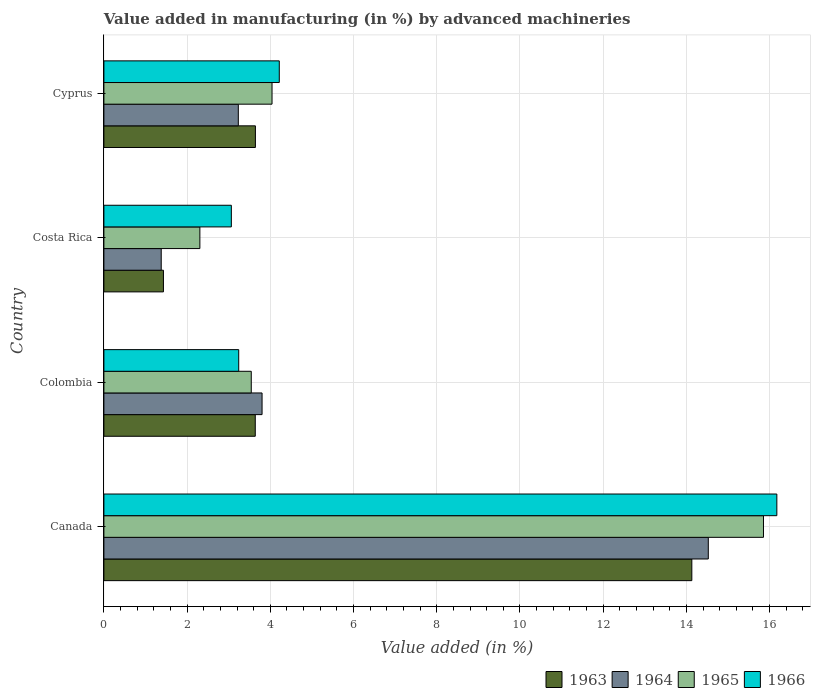Are the number of bars per tick equal to the number of legend labels?
Your answer should be compact. Yes. Are the number of bars on each tick of the Y-axis equal?
Your answer should be very brief. Yes. How many bars are there on the 1st tick from the bottom?
Give a very brief answer. 4. What is the label of the 1st group of bars from the top?
Offer a terse response. Cyprus. In how many cases, is the number of bars for a given country not equal to the number of legend labels?
Keep it short and to the point. 0. What is the percentage of value added in manufacturing by advanced machineries in 1964 in Canada?
Make the answer very short. 14.53. Across all countries, what is the maximum percentage of value added in manufacturing by advanced machineries in 1966?
Make the answer very short. 16.17. Across all countries, what is the minimum percentage of value added in manufacturing by advanced machineries in 1966?
Ensure brevity in your answer.  3.06. In which country was the percentage of value added in manufacturing by advanced machineries in 1964 minimum?
Provide a short and direct response. Costa Rica. What is the total percentage of value added in manufacturing by advanced machineries in 1966 in the graph?
Make the answer very short. 26.69. What is the difference between the percentage of value added in manufacturing by advanced machineries in 1966 in Colombia and that in Costa Rica?
Make the answer very short. 0.18. What is the difference between the percentage of value added in manufacturing by advanced machineries in 1966 in Colombia and the percentage of value added in manufacturing by advanced machineries in 1965 in Costa Rica?
Make the answer very short. 0.93. What is the average percentage of value added in manufacturing by advanced machineries in 1966 per country?
Your answer should be very brief. 6.67. What is the difference between the percentage of value added in manufacturing by advanced machineries in 1963 and percentage of value added in manufacturing by advanced machineries in 1965 in Cyprus?
Provide a short and direct response. -0.4. What is the ratio of the percentage of value added in manufacturing by advanced machineries in 1965 in Costa Rica to that in Cyprus?
Your response must be concise. 0.57. Is the difference between the percentage of value added in manufacturing by advanced machineries in 1963 in Colombia and Cyprus greater than the difference between the percentage of value added in manufacturing by advanced machineries in 1965 in Colombia and Cyprus?
Offer a very short reply. Yes. What is the difference between the highest and the second highest percentage of value added in manufacturing by advanced machineries in 1963?
Ensure brevity in your answer.  10.49. What is the difference between the highest and the lowest percentage of value added in manufacturing by advanced machineries in 1964?
Make the answer very short. 13.15. What does the 3rd bar from the top in Colombia represents?
Your response must be concise. 1964. What does the 1st bar from the bottom in Costa Rica represents?
Provide a short and direct response. 1963. How many countries are there in the graph?
Your answer should be very brief. 4. Does the graph contain any zero values?
Give a very brief answer. No. How are the legend labels stacked?
Offer a very short reply. Horizontal. What is the title of the graph?
Offer a terse response. Value added in manufacturing (in %) by advanced machineries. Does "1994" appear as one of the legend labels in the graph?
Your answer should be very brief. No. What is the label or title of the X-axis?
Offer a terse response. Value added (in %). What is the label or title of the Y-axis?
Ensure brevity in your answer.  Country. What is the Value added (in %) of 1963 in Canada?
Provide a succinct answer. 14.13. What is the Value added (in %) of 1964 in Canada?
Offer a terse response. 14.53. What is the Value added (in %) in 1965 in Canada?
Offer a terse response. 15.85. What is the Value added (in %) of 1966 in Canada?
Provide a short and direct response. 16.17. What is the Value added (in %) of 1963 in Colombia?
Keep it short and to the point. 3.64. What is the Value added (in %) of 1964 in Colombia?
Offer a very short reply. 3.8. What is the Value added (in %) in 1965 in Colombia?
Make the answer very short. 3.54. What is the Value added (in %) of 1966 in Colombia?
Your answer should be very brief. 3.24. What is the Value added (in %) in 1963 in Costa Rica?
Provide a short and direct response. 1.43. What is the Value added (in %) in 1964 in Costa Rica?
Your answer should be compact. 1.38. What is the Value added (in %) of 1965 in Costa Rica?
Your answer should be very brief. 2.31. What is the Value added (in %) of 1966 in Costa Rica?
Provide a short and direct response. 3.06. What is the Value added (in %) in 1963 in Cyprus?
Offer a very short reply. 3.64. What is the Value added (in %) in 1964 in Cyprus?
Ensure brevity in your answer.  3.23. What is the Value added (in %) of 1965 in Cyprus?
Ensure brevity in your answer.  4.04. What is the Value added (in %) of 1966 in Cyprus?
Ensure brevity in your answer.  4.22. Across all countries, what is the maximum Value added (in %) in 1963?
Keep it short and to the point. 14.13. Across all countries, what is the maximum Value added (in %) of 1964?
Offer a very short reply. 14.53. Across all countries, what is the maximum Value added (in %) of 1965?
Offer a very short reply. 15.85. Across all countries, what is the maximum Value added (in %) in 1966?
Provide a short and direct response. 16.17. Across all countries, what is the minimum Value added (in %) in 1963?
Your answer should be very brief. 1.43. Across all countries, what is the minimum Value added (in %) of 1964?
Provide a short and direct response. 1.38. Across all countries, what is the minimum Value added (in %) in 1965?
Your answer should be very brief. 2.31. Across all countries, what is the minimum Value added (in %) of 1966?
Provide a succinct answer. 3.06. What is the total Value added (in %) of 1963 in the graph?
Offer a very short reply. 22.84. What is the total Value added (in %) of 1964 in the graph?
Provide a succinct answer. 22.94. What is the total Value added (in %) of 1965 in the graph?
Offer a terse response. 25.74. What is the total Value added (in %) of 1966 in the graph?
Ensure brevity in your answer.  26.69. What is the difference between the Value added (in %) of 1963 in Canada and that in Colombia?
Your response must be concise. 10.49. What is the difference between the Value added (in %) of 1964 in Canada and that in Colombia?
Offer a very short reply. 10.72. What is the difference between the Value added (in %) in 1965 in Canada and that in Colombia?
Provide a succinct answer. 12.31. What is the difference between the Value added (in %) in 1966 in Canada and that in Colombia?
Make the answer very short. 12.93. What is the difference between the Value added (in %) in 1963 in Canada and that in Costa Rica?
Provide a succinct answer. 12.7. What is the difference between the Value added (in %) of 1964 in Canada and that in Costa Rica?
Your response must be concise. 13.15. What is the difference between the Value added (in %) of 1965 in Canada and that in Costa Rica?
Offer a terse response. 13.55. What is the difference between the Value added (in %) of 1966 in Canada and that in Costa Rica?
Your answer should be very brief. 13.11. What is the difference between the Value added (in %) of 1963 in Canada and that in Cyprus?
Make the answer very short. 10.49. What is the difference between the Value added (in %) of 1964 in Canada and that in Cyprus?
Offer a terse response. 11.3. What is the difference between the Value added (in %) of 1965 in Canada and that in Cyprus?
Provide a short and direct response. 11.81. What is the difference between the Value added (in %) of 1966 in Canada and that in Cyprus?
Make the answer very short. 11.96. What is the difference between the Value added (in %) of 1963 in Colombia and that in Costa Rica?
Provide a short and direct response. 2.21. What is the difference between the Value added (in %) in 1964 in Colombia and that in Costa Rica?
Your answer should be compact. 2.42. What is the difference between the Value added (in %) in 1965 in Colombia and that in Costa Rica?
Provide a succinct answer. 1.24. What is the difference between the Value added (in %) of 1966 in Colombia and that in Costa Rica?
Make the answer very short. 0.18. What is the difference between the Value added (in %) in 1963 in Colombia and that in Cyprus?
Offer a very short reply. -0. What is the difference between the Value added (in %) of 1964 in Colombia and that in Cyprus?
Make the answer very short. 0.57. What is the difference between the Value added (in %) in 1965 in Colombia and that in Cyprus?
Give a very brief answer. -0.5. What is the difference between the Value added (in %) in 1966 in Colombia and that in Cyprus?
Make the answer very short. -0.97. What is the difference between the Value added (in %) in 1963 in Costa Rica and that in Cyprus?
Offer a very short reply. -2.21. What is the difference between the Value added (in %) of 1964 in Costa Rica and that in Cyprus?
Your answer should be very brief. -1.85. What is the difference between the Value added (in %) in 1965 in Costa Rica and that in Cyprus?
Offer a very short reply. -1.73. What is the difference between the Value added (in %) in 1966 in Costa Rica and that in Cyprus?
Offer a terse response. -1.15. What is the difference between the Value added (in %) of 1963 in Canada and the Value added (in %) of 1964 in Colombia?
Give a very brief answer. 10.33. What is the difference between the Value added (in %) of 1963 in Canada and the Value added (in %) of 1965 in Colombia?
Your response must be concise. 10.59. What is the difference between the Value added (in %) in 1963 in Canada and the Value added (in %) in 1966 in Colombia?
Keep it short and to the point. 10.89. What is the difference between the Value added (in %) in 1964 in Canada and the Value added (in %) in 1965 in Colombia?
Give a very brief answer. 10.98. What is the difference between the Value added (in %) in 1964 in Canada and the Value added (in %) in 1966 in Colombia?
Give a very brief answer. 11.29. What is the difference between the Value added (in %) of 1965 in Canada and the Value added (in %) of 1966 in Colombia?
Make the answer very short. 12.61. What is the difference between the Value added (in %) in 1963 in Canada and the Value added (in %) in 1964 in Costa Rica?
Provide a succinct answer. 12.75. What is the difference between the Value added (in %) of 1963 in Canada and the Value added (in %) of 1965 in Costa Rica?
Make the answer very short. 11.82. What is the difference between the Value added (in %) in 1963 in Canada and the Value added (in %) in 1966 in Costa Rica?
Offer a very short reply. 11.07. What is the difference between the Value added (in %) in 1964 in Canada and the Value added (in %) in 1965 in Costa Rica?
Your response must be concise. 12.22. What is the difference between the Value added (in %) of 1964 in Canada and the Value added (in %) of 1966 in Costa Rica?
Provide a short and direct response. 11.46. What is the difference between the Value added (in %) of 1965 in Canada and the Value added (in %) of 1966 in Costa Rica?
Your answer should be very brief. 12.79. What is the difference between the Value added (in %) in 1963 in Canada and the Value added (in %) in 1964 in Cyprus?
Offer a terse response. 10.9. What is the difference between the Value added (in %) of 1963 in Canada and the Value added (in %) of 1965 in Cyprus?
Offer a terse response. 10.09. What is the difference between the Value added (in %) in 1963 in Canada and the Value added (in %) in 1966 in Cyprus?
Give a very brief answer. 9.92. What is the difference between the Value added (in %) in 1964 in Canada and the Value added (in %) in 1965 in Cyprus?
Your answer should be compact. 10.49. What is the difference between the Value added (in %) in 1964 in Canada and the Value added (in %) in 1966 in Cyprus?
Offer a terse response. 10.31. What is the difference between the Value added (in %) in 1965 in Canada and the Value added (in %) in 1966 in Cyprus?
Keep it short and to the point. 11.64. What is the difference between the Value added (in %) in 1963 in Colombia and the Value added (in %) in 1964 in Costa Rica?
Provide a succinct answer. 2.26. What is the difference between the Value added (in %) in 1963 in Colombia and the Value added (in %) in 1965 in Costa Rica?
Offer a terse response. 1.33. What is the difference between the Value added (in %) of 1963 in Colombia and the Value added (in %) of 1966 in Costa Rica?
Your answer should be compact. 0.57. What is the difference between the Value added (in %) in 1964 in Colombia and the Value added (in %) in 1965 in Costa Rica?
Offer a terse response. 1.49. What is the difference between the Value added (in %) of 1964 in Colombia and the Value added (in %) of 1966 in Costa Rica?
Make the answer very short. 0.74. What is the difference between the Value added (in %) of 1965 in Colombia and the Value added (in %) of 1966 in Costa Rica?
Give a very brief answer. 0.48. What is the difference between the Value added (in %) of 1963 in Colombia and the Value added (in %) of 1964 in Cyprus?
Keep it short and to the point. 0.41. What is the difference between the Value added (in %) in 1963 in Colombia and the Value added (in %) in 1965 in Cyprus?
Your answer should be very brief. -0.4. What is the difference between the Value added (in %) of 1963 in Colombia and the Value added (in %) of 1966 in Cyprus?
Offer a terse response. -0.58. What is the difference between the Value added (in %) of 1964 in Colombia and the Value added (in %) of 1965 in Cyprus?
Make the answer very short. -0.24. What is the difference between the Value added (in %) of 1964 in Colombia and the Value added (in %) of 1966 in Cyprus?
Your answer should be very brief. -0.41. What is the difference between the Value added (in %) of 1965 in Colombia and the Value added (in %) of 1966 in Cyprus?
Your response must be concise. -0.67. What is the difference between the Value added (in %) in 1963 in Costa Rica and the Value added (in %) in 1964 in Cyprus?
Your response must be concise. -1.8. What is the difference between the Value added (in %) of 1963 in Costa Rica and the Value added (in %) of 1965 in Cyprus?
Make the answer very short. -2.61. What is the difference between the Value added (in %) of 1963 in Costa Rica and the Value added (in %) of 1966 in Cyprus?
Give a very brief answer. -2.78. What is the difference between the Value added (in %) of 1964 in Costa Rica and the Value added (in %) of 1965 in Cyprus?
Give a very brief answer. -2.66. What is the difference between the Value added (in %) of 1964 in Costa Rica and the Value added (in %) of 1966 in Cyprus?
Ensure brevity in your answer.  -2.84. What is the difference between the Value added (in %) of 1965 in Costa Rica and the Value added (in %) of 1966 in Cyprus?
Give a very brief answer. -1.91. What is the average Value added (in %) of 1963 per country?
Make the answer very short. 5.71. What is the average Value added (in %) of 1964 per country?
Your response must be concise. 5.73. What is the average Value added (in %) in 1965 per country?
Offer a terse response. 6.44. What is the average Value added (in %) of 1966 per country?
Give a very brief answer. 6.67. What is the difference between the Value added (in %) of 1963 and Value added (in %) of 1964 in Canada?
Provide a succinct answer. -0.4. What is the difference between the Value added (in %) in 1963 and Value added (in %) in 1965 in Canada?
Your response must be concise. -1.72. What is the difference between the Value added (in %) in 1963 and Value added (in %) in 1966 in Canada?
Your response must be concise. -2.04. What is the difference between the Value added (in %) in 1964 and Value added (in %) in 1965 in Canada?
Provide a short and direct response. -1.33. What is the difference between the Value added (in %) of 1964 and Value added (in %) of 1966 in Canada?
Your answer should be very brief. -1.65. What is the difference between the Value added (in %) in 1965 and Value added (in %) in 1966 in Canada?
Offer a terse response. -0.32. What is the difference between the Value added (in %) in 1963 and Value added (in %) in 1964 in Colombia?
Offer a terse response. -0.16. What is the difference between the Value added (in %) of 1963 and Value added (in %) of 1965 in Colombia?
Give a very brief answer. 0.1. What is the difference between the Value added (in %) in 1963 and Value added (in %) in 1966 in Colombia?
Make the answer very short. 0.4. What is the difference between the Value added (in %) in 1964 and Value added (in %) in 1965 in Colombia?
Your answer should be very brief. 0.26. What is the difference between the Value added (in %) in 1964 and Value added (in %) in 1966 in Colombia?
Provide a short and direct response. 0.56. What is the difference between the Value added (in %) in 1965 and Value added (in %) in 1966 in Colombia?
Make the answer very short. 0.3. What is the difference between the Value added (in %) of 1963 and Value added (in %) of 1964 in Costa Rica?
Provide a succinct answer. 0.05. What is the difference between the Value added (in %) of 1963 and Value added (in %) of 1965 in Costa Rica?
Your response must be concise. -0.88. What is the difference between the Value added (in %) of 1963 and Value added (in %) of 1966 in Costa Rica?
Give a very brief answer. -1.63. What is the difference between the Value added (in %) of 1964 and Value added (in %) of 1965 in Costa Rica?
Your answer should be very brief. -0.93. What is the difference between the Value added (in %) of 1964 and Value added (in %) of 1966 in Costa Rica?
Make the answer very short. -1.69. What is the difference between the Value added (in %) in 1965 and Value added (in %) in 1966 in Costa Rica?
Give a very brief answer. -0.76. What is the difference between the Value added (in %) of 1963 and Value added (in %) of 1964 in Cyprus?
Give a very brief answer. 0.41. What is the difference between the Value added (in %) in 1963 and Value added (in %) in 1965 in Cyprus?
Your answer should be compact. -0.4. What is the difference between the Value added (in %) of 1963 and Value added (in %) of 1966 in Cyprus?
Ensure brevity in your answer.  -0.57. What is the difference between the Value added (in %) in 1964 and Value added (in %) in 1965 in Cyprus?
Keep it short and to the point. -0.81. What is the difference between the Value added (in %) in 1964 and Value added (in %) in 1966 in Cyprus?
Make the answer very short. -0.98. What is the difference between the Value added (in %) in 1965 and Value added (in %) in 1966 in Cyprus?
Give a very brief answer. -0.17. What is the ratio of the Value added (in %) in 1963 in Canada to that in Colombia?
Provide a succinct answer. 3.88. What is the ratio of the Value added (in %) of 1964 in Canada to that in Colombia?
Your response must be concise. 3.82. What is the ratio of the Value added (in %) in 1965 in Canada to that in Colombia?
Provide a succinct answer. 4.48. What is the ratio of the Value added (in %) of 1966 in Canada to that in Colombia?
Provide a short and direct response. 4.99. What is the ratio of the Value added (in %) in 1963 in Canada to that in Costa Rica?
Your answer should be compact. 9.87. What is the ratio of the Value added (in %) of 1964 in Canada to that in Costa Rica?
Your answer should be compact. 10.54. What is the ratio of the Value added (in %) of 1965 in Canada to that in Costa Rica?
Provide a short and direct response. 6.87. What is the ratio of the Value added (in %) in 1966 in Canada to that in Costa Rica?
Provide a succinct answer. 5.28. What is the ratio of the Value added (in %) in 1963 in Canada to that in Cyprus?
Your answer should be very brief. 3.88. What is the ratio of the Value added (in %) of 1964 in Canada to that in Cyprus?
Make the answer very short. 4.5. What is the ratio of the Value added (in %) of 1965 in Canada to that in Cyprus?
Give a very brief answer. 3.92. What is the ratio of the Value added (in %) of 1966 in Canada to that in Cyprus?
Give a very brief answer. 3.84. What is the ratio of the Value added (in %) of 1963 in Colombia to that in Costa Rica?
Give a very brief answer. 2.54. What is the ratio of the Value added (in %) of 1964 in Colombia to that in Costa Rica?
Provide a succinct answer. 2.76. What is the ratio of the Value added (in %) of 1965 in Colombia to that in Costa Rica?
Offer a very short reply. 1.54. What is the ratio of the Value added (in %) of 1966 in Colombia to that in Costa Rica?
Your response must be concise. 1.06. What is the ratio of the Value added (in %) of 1963 in Colombia to that in Cyprus?
Offer a terse response. 1. What is the ratio of the Value added (in %) in 1964 in Colombia to that in Cyprus?
Offer a very short reply. 1.18. What is the ratio of the Value added (in %) in 1965 in Colombia to that in Cyprus?
Provide a short and direct response. 0.88. What is the ratio of the Value added (in %) of 1966 in Colombia to that in Cyprus?
Keep it short and to the point. 0.77. What is the ratio of the Value added (in %) of 1963 in Costa Rica to that in Cyprus?
Your answer should be very brief. 0.39. What is the ratio of the Value added (in %) of 1964 in Costa Rica to that in Cyprus?
Your response must be concise. 0.43. What is the ratio of the Value added (in %) of 1965 in Costa Rica to that in Cyprus?
Ensure brevity in your answer.  0.57. What is the ratio of the Value added (in %) of 1966 in Costa Rica to that in Cyprus?
Your answer should be compact. 0.73. What is the difference between the highest and the second highest Value added (in %) in 1963?
Ensure brevity in your answer.  10.49. What is the difference between the highest and the second highest Value added (in %) of 1964?
Provide a succinct answer. 10.72. What is the difference between the highest and the second highest Value added (in %) in 1965?
Provide a short and direct response. 11.81. What is the difference between the highest and the second highest Value added (in %) of 1966?
Provide a succinct answer. 11.96. What is the difference between the highest and the lowest Value added (in %) of 1963?
Ensure brevity in your answer.  12.7. What is the difference between the highest and the lowest Value added (in %) in 1964?
Ensure brevity in your answer.  13.15. What is the difference between the highest and the lowest Value added (in %) in 1965?
Your answer should be very brief. 13.55. What is the difference between the highest and the lowest Value added (in %) of 1966?
Offer a terse response. 13.11. 